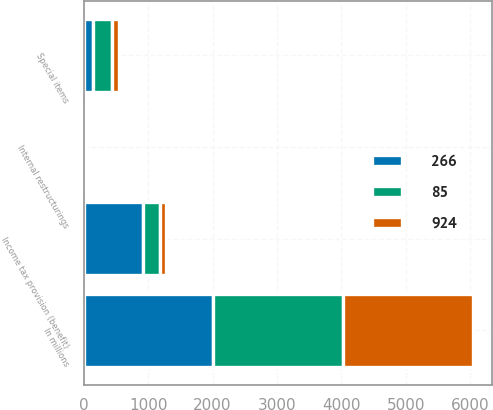Convert chart. <chart><loc_0><loc_0><loc_500><loc_500><stacked_bar_chart><ecel><fcel>In millions<fcel>Special items<fcel>Internal restructurings<fcel>Income tax provision (benefit)<nl><fcel>266<fcel>2013<fcel>151<fcel>4<fcel>924<nl><fcel>924<fcel>2012<fcel>104<fcel>14<fcel>85<nl><fcel>85<fcel>2011<fcel>293<fcel>24<fcel>266<nl></chart> 